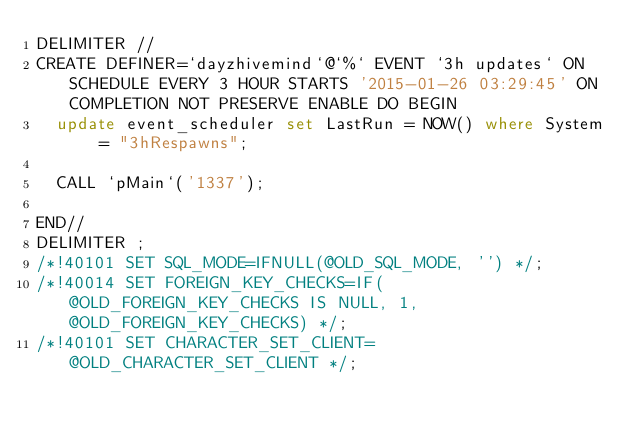Convert code to text. <code><loc_0><loc_0><loc_500><loc_500><_SQL_>DELIMITER //
CREATE DEFINER=`dayzhivemind`@`%` EVENT `3h updates` ON SCHEDULE EVERY 3 HOUR STARTS '2015-01-26 03:29:45' ON COMPLETION NOT PRESERVE ENABLE DO BEGIN
	update event_scheduler set LastRun = NOW() where System = "3hRespawns";
	
	CALL `pMain`('1337');
	
END//
DELIMITER ;
/*!40101 SET SQL_MODE=IFNULL(@OLD_SQL_MODE, '') */;
/*!40014 SET FOREIGN_KEY_CHECKS=IF(@OLD_FOREIGN_KEY_CHECKS IS NULL, 1, @OLD_FOREIGN_KEY_CHECKS) */;
/*!40101 SET CHARACTER_SET_CLIENT=@OLD_CHARACTER_SET_CLIENT */;
</code> 